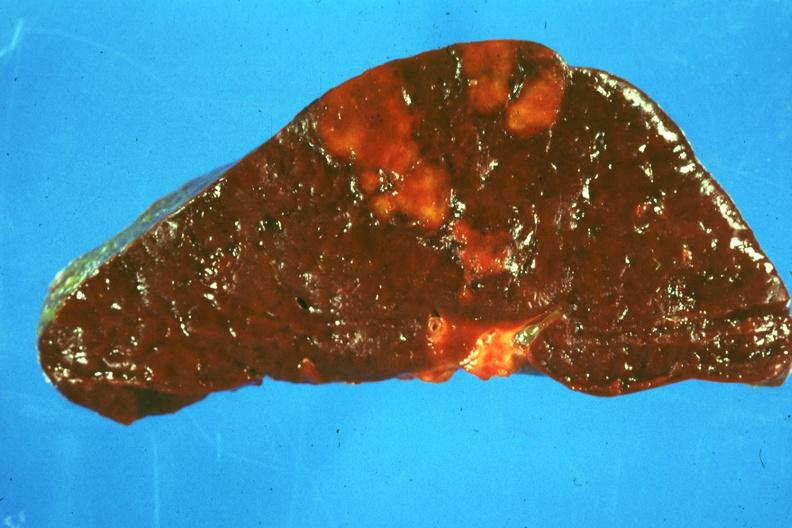s infarct present?
Answer the question using a single word or phrase. Yes 